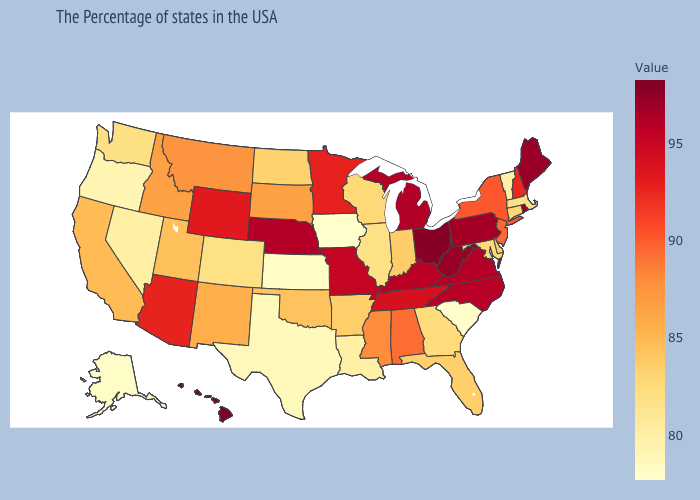Does Nevada have a higher value than South Carolina?
Write a very short answer. Yes. Does the map have missing data?
Be succinct. No. Does Washington have a higher value than Rhode Island?
Answer briefly. No. Which states have the lowest value in the USA?
Write a very short answer. Iowa. Does Mississippi have the lowest value in the South?
Answer briefly. No. 